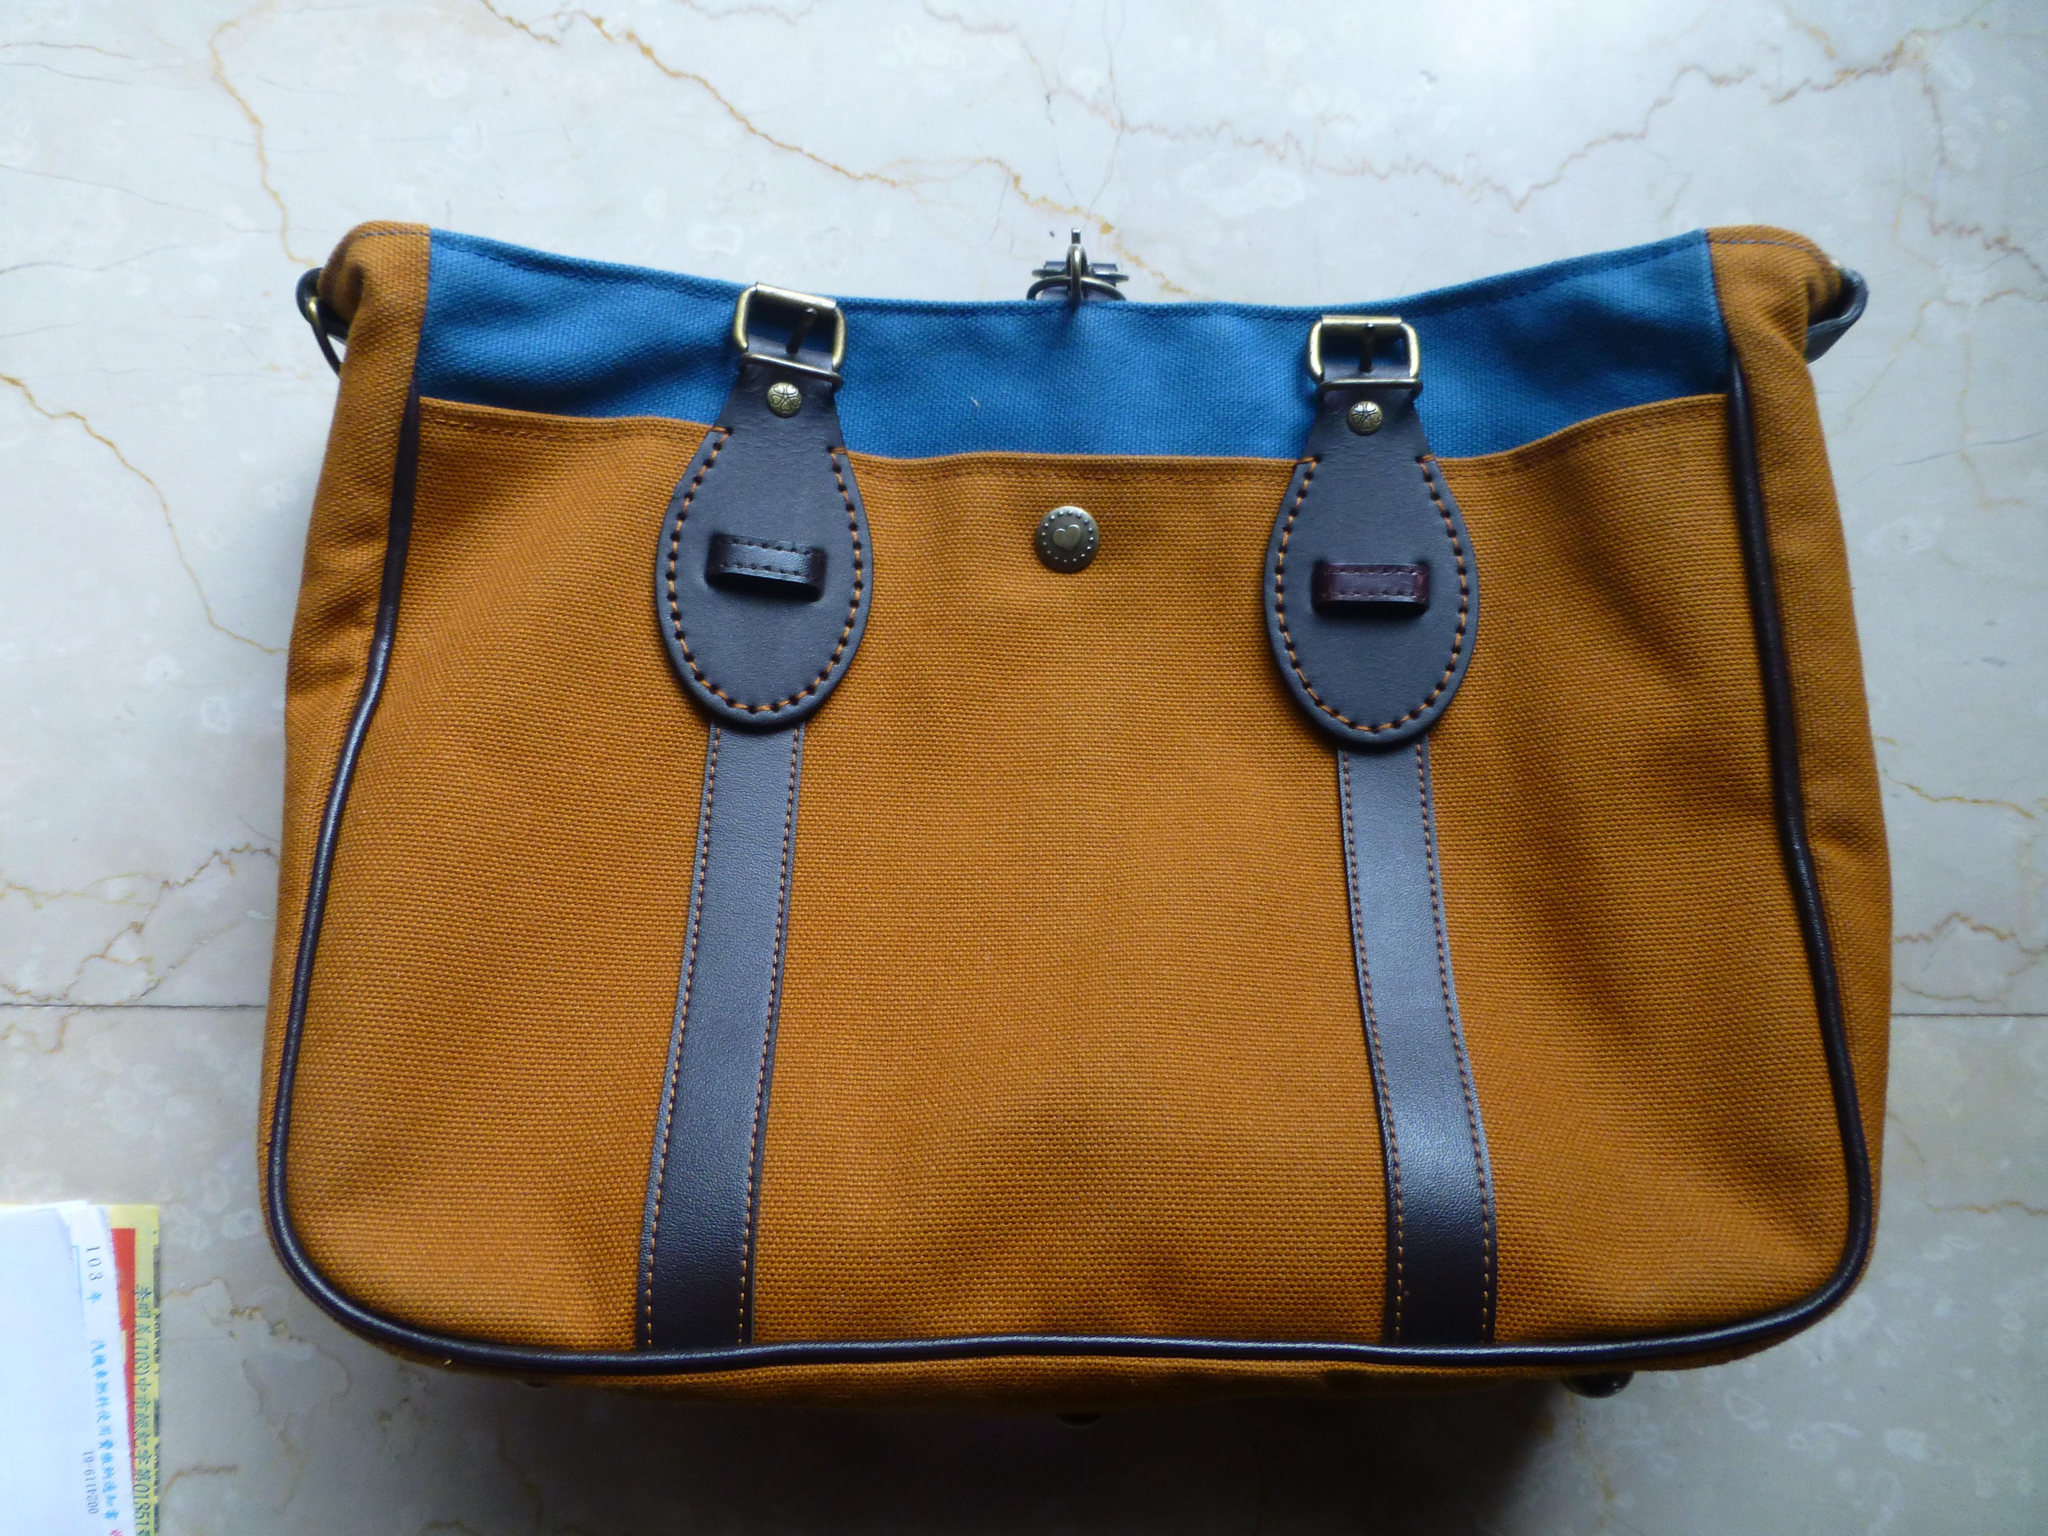What object can be seen in the image that might be used for carrying items? There is a bag in the image that might be used for carrying items. What can you tell me about the colors of the bag? The bag has mixed colors: blue, brown, and black. What other object can be seen in the image besides the bag? There is a book in the image. Where is the book located in relation to the bag? The book is besides the bag. What type of animal can be seen interacting with the bag in the image? There is no animal present in the image, and therefore no such interaction can be observed. What sound does the bell make in the image? There is no bell present in the image. 